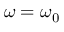Convert formula to latex. <formula><loc_0><loc_0><loc_500><loc_500>\omega = \omega _ { 0 }</formula> 